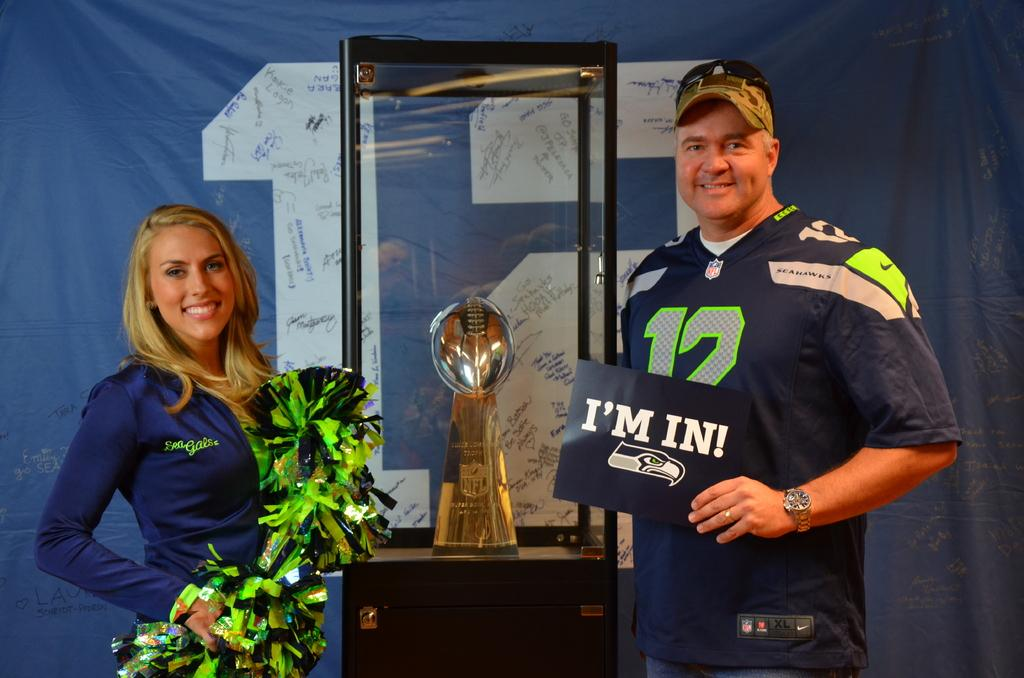<image>
Create a compact narrative representing the image presented. A man poses with an NFL trophy and one of the Sea Gals. 